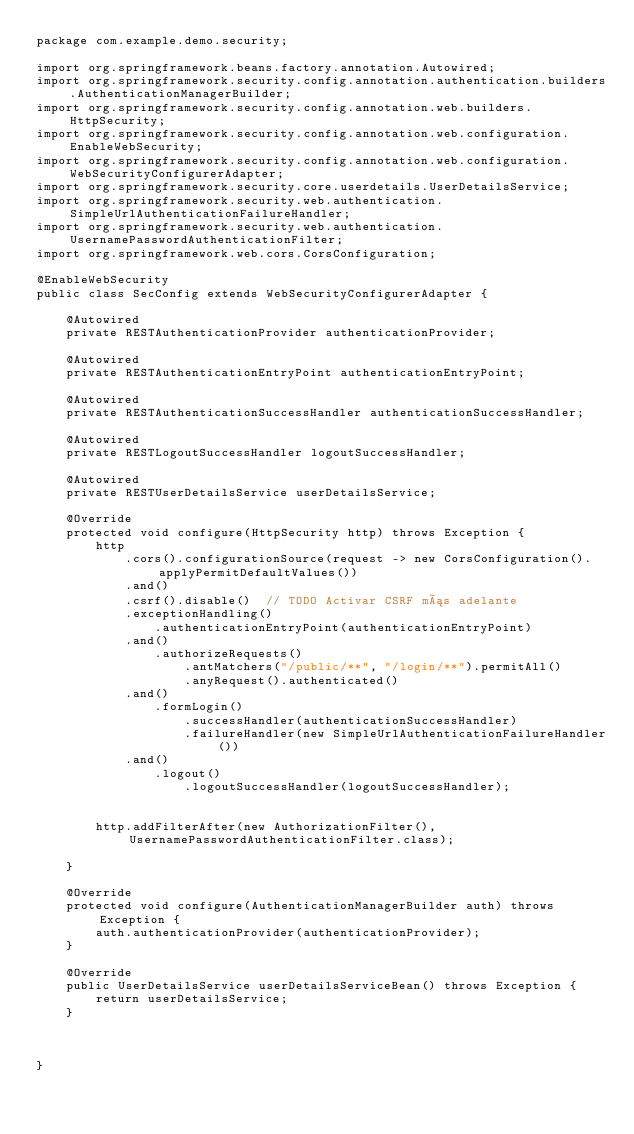Convert code to text. <code><loc_0><loc_0><loc_500><loc_500><_Java_>package com.example.demo.security;

import org.springframework.beans.factory.annotation.Autowired;
import org.springframework.security.config.annotation.authentication.builders.AuthenticationManagerBuilder;
import org.springframework.security.config.annotation.web.builders.HttpSecurity;
import org.springframework.security.config.annotation.web.configuration.EnableWebSecurity;
import org.springframework.security.config.annotation.web.configuration.WebSecurityConfigurerAdapter;
import org.springframework.security.core.userdetails.UserDetailsService;
import org.springframework.security.web.authentication.SimpleUrlAuthenticationFailureHandler;
import org.springframework.security.web.authentication.UsernamePasswordAuthenticationFilter;
import org.springframework.web.cors.CorsConfiguration;

@EnableWebSecurity
public class SecConfig extends WebSecurityConfigurerAdapter {

	@Autowired
	private RESTAuthenticationProvider authenticationProvider;
	
	@Autowired
	private RESTAuthenticationEntryPoint authenticationEntryPoint;
	
	@Autowired
	private RESTAuthenticationSuccessHandler authenticationSuccessHandler;
	
	@Autowired
	private RESTLogoutSuccessHandler logoutSuccessHandler;

	@Autowired
	private RESTUserDetailsService userDetailsService;
	
	@Override
	protected void configure(HttpSecurity http) throws Exception {
		http
			.cors().configurationSource(request -> new CorsConfiguration().applyPermitDefaultValues())
			.and()
			.csrf().disable()  // TODO Activar CSRF más adelante
			.exceptionHandling()
				.authenticationEntryPoint(authenticationEntryPoint)
			.and()
				.authorizeRequests()
					.antMatchers("/public/**", "/login/**").permitAll()
					.anyRequest().authenticated()
			.and()
				.formLogin()
					.successHandler(authenticationSuccessHandler)
					.failureHandler(new SimpleUrlAuthenticationFailureHandler())
			.and()
				.logout()
					.logoutSuccessHandler(logoutSuccessHandler);
				
		
		http.addFilterAfter(new AuthorizationFilter(), UsernamePasswordAuthenticationFilter.class);
		
	}

	@Override
	protected void configure(AuthenticationManagerBuilder auth) throws Exception {
		auth.authenticationProvider(authenticationProvider);
	}

	@Override
	public UserDetailsService userDetailsServiceBean() throws Exception {
		return userDetailsService;
	}


	
}
</code> 